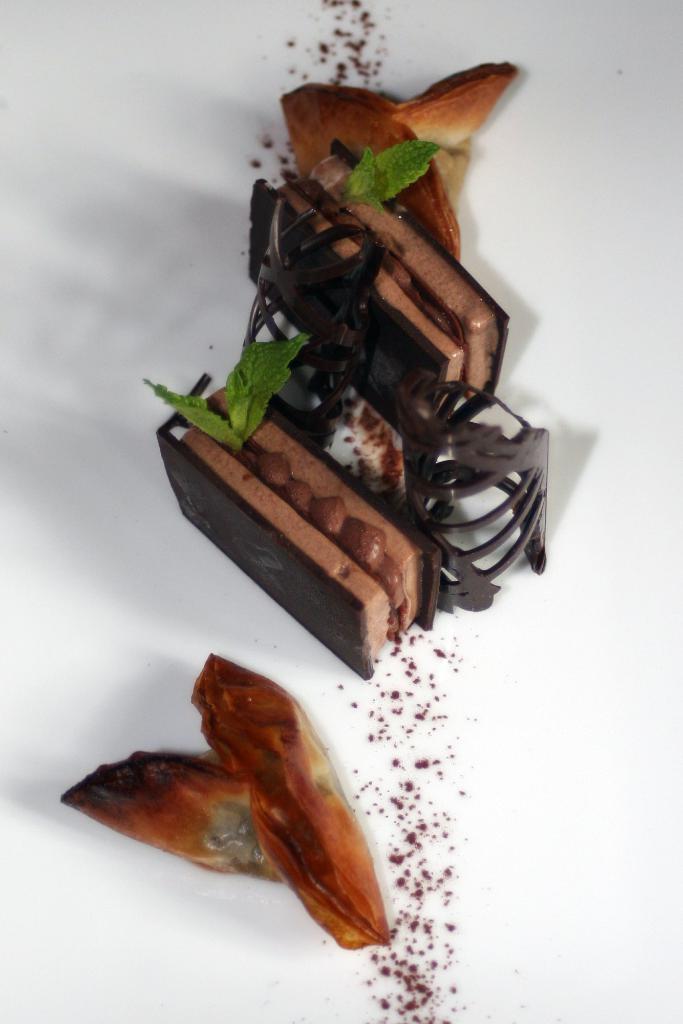Please provide a concise description of this image. Here I can see two biscuits along with chocolate cream and few leaves. The background is in white color. 